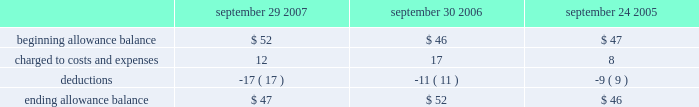Notes to consolidated financial statements ( continued ) note 2 2014financial instruments ( continued ) covered by collateral , third-party flooring arrangements , or credit insurance are outstanding with the company 2019s distribution and retail channel partners .
One customer accounted for approximately 11% ( 11 % ) of trade receivables as of september 29 , 2007 , while no customers accounted for more than 10% ( 10 % ) of trade receivables as of september 30 , 2006 .
The table summarizes the activity in the allowance for doubtful accounts ( in millions ) : september 29 , september 30 , september 24 , 2007 2006 2005 .
Vendor non-trade receivables the company has non-trade receivables from certain of its manufacturing vendors resulting from the sale of raw material components to these manufacturing vendors who manufacture sub-assemblies or assemble final products for the company .
The company purchases these raw material components directly from suppliers .
These non-trade receivables , which are included in the consolidated balance sheets in other current assets , totaled $ 2.4 billion and $ 1.6 billion as of september 29 , 2007 and september 30 , 2006 , respectively .
The company does not reflect the sale of these components in net sales and does not recognize any profits on these sales until the products are sold through to the end customer at which time the profit is recognized as a reduction of cost of sales .
Derivative financial instruments the company uses derivatives to partially offset its business exposure to foreign exchange risk .
Foreign currency forward and option contracts are used to offset the foreign exchange risk on certain existing assets and liabilities and to hedge the foreign exchange risk on expected future cash flows on certain forecasted revenue and cost of sales .
The company 2019s accounting policies for these instruments are based on whether the instruments are designated as hedge or non-hedge instruments .
The company records all derivatives on the balance sheet at fair value. .
What was the percentage change in the allowance for doubtful accounts from 2005 to 2006? 
Computations: ((52 - 46) / 46)
Answer: 0.13043. 